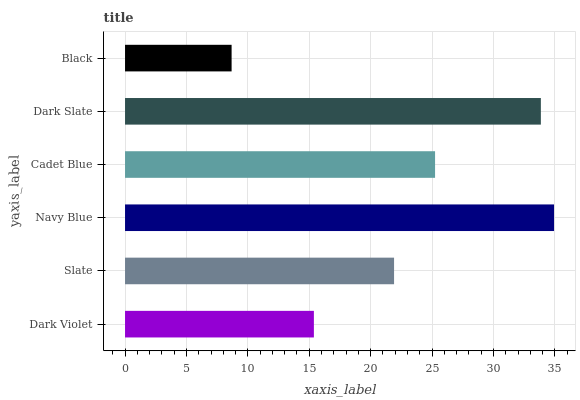Is Black the minimum?
Answer yes or no. Yes. Is Navy Blue the maximum?
Answer yes or no. Yes. Is Slate the minimum?
Answer yes or no. No. Is Slate the maximum?
Answer yes or no. No. Is Slate greater than Dark Violet?
Answer yes or no. Yes. Is Dark Violet less than Slate?
Answer yes or no. Yes. Is Dark Violet greater than Slate?
Answer yes or no. No. Is Slate less than Dark Violet?
Answer yes or no. No. Is Cadet Blue the high median?
Answer yes or no. Yes. Is Slate the low median?
Answer yes or no. Yes. Is Dark Slate the high median?
Answer yes or no. No. Is Dark Slate the low median?
Answer yes or no. No. 